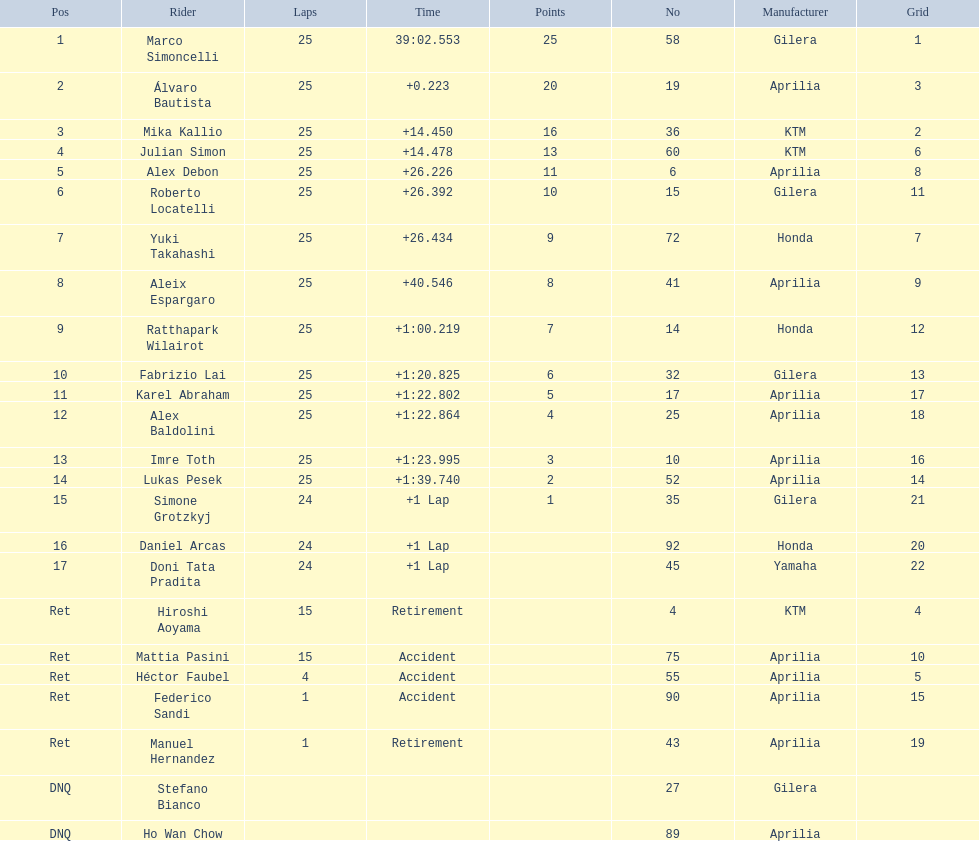How many laps did hiroshi aoyama perform? 15. How many laps did marco simoncelli perform? 25. Who performed more laps out of hiroshi aoyama and marco 
simoncelli? Marco Simoncelli. 